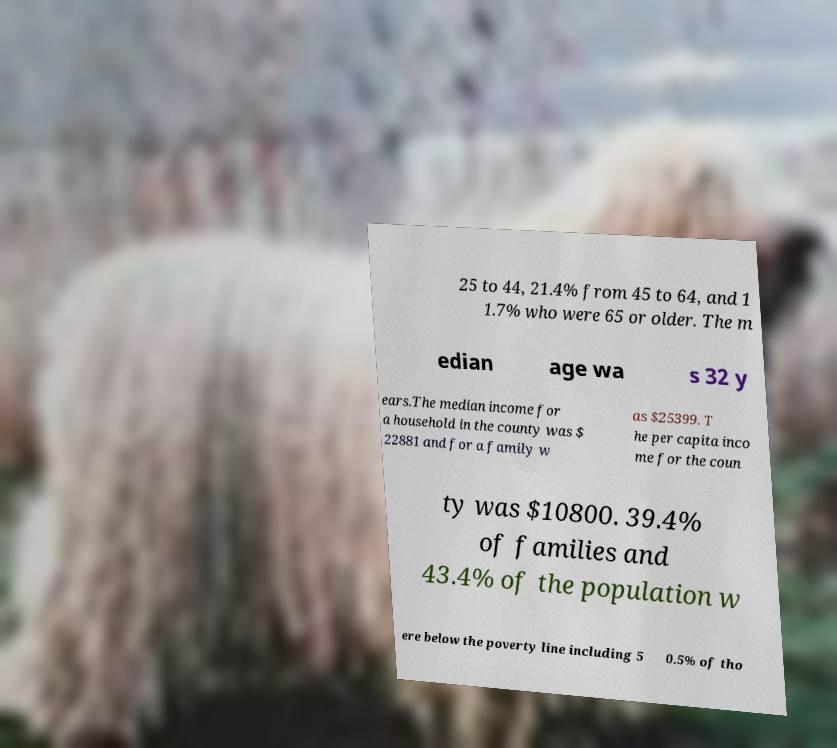Could you assist in decoding the text presented in this image and type it out clearly? 25 to 44, 21.4% from 45 to 64, and 1 1.7% who were 65 or older. The m edian age wa s 32 y ears.The median income for a household in the county was $ 22881 and for a family w as $25399. T he per capita inco me for the coun ty was $10800. 39.4% of families and 43.4% of the population w ere below the poverty line including 5 0.5% of tho 